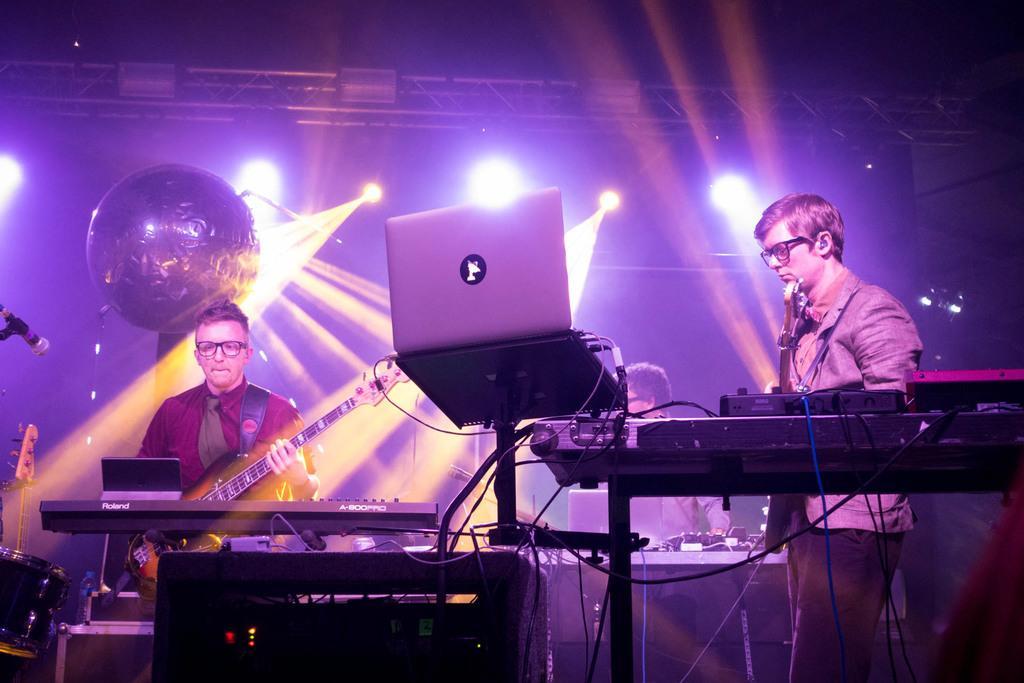Can you describe this image briefly? In the image we can see there are people who are standing and they are playing musical instruments. 